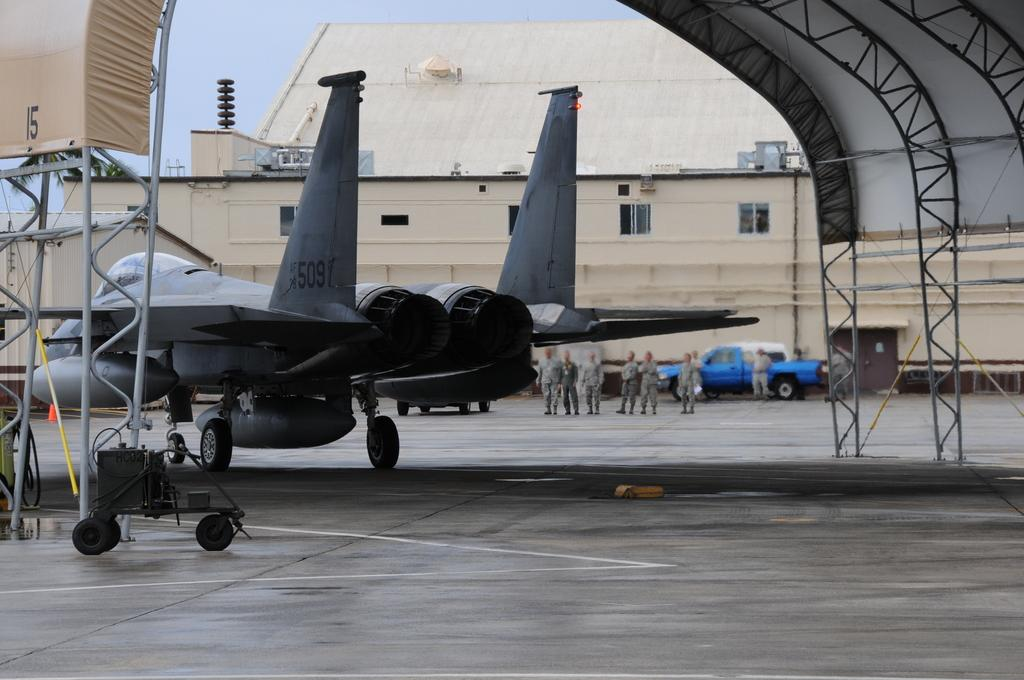<image>
Describe the image concisely. Airplane number 509 getting ready to take off. 